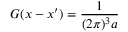Convert formula to latex. <formula><loc_0><loc_0><loc_500><loc_500>G ( x - x ^ { \prime } ) = \frac { 1 } { ( 2 \pi ) ^ { 3 } a }</formula> 